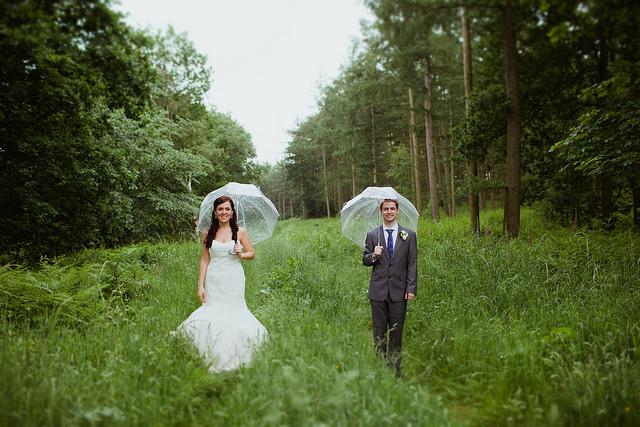How many umbrellas are open?
Give a very brief answer. 2. What color are their umbrellas?
Short answer required. Clear. Based on the trees, what season does it appear to be?
Write a very short answer. Summer. Where are they going?
Keep it brief. Wedding. 